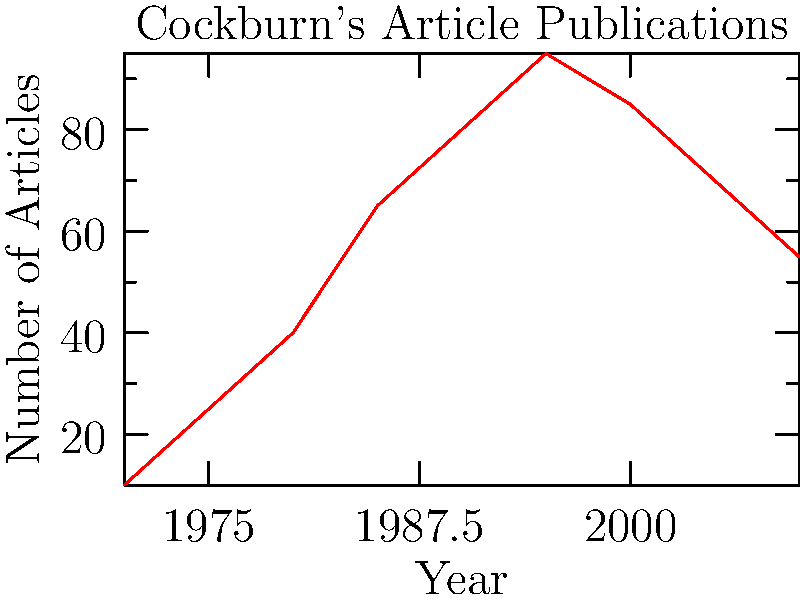Analyze the trend in Alexander Cockburn's article publications from 1970 to 2010 as shown in the line graph. What significant shift occurred around the year 2000, and how might this relate to changes in the media landscape during that period? To answer this question, we need to examine the line graph carefully and interpret the data in the context of media studies:

1. Observe the overall trend: From 1970 to 2000, there's a steady increase in the number of articles published by Cockburn.

2. Identify the peak: The number of articles reaches its maximum around 1995-2000, with approximately 95 articles published.

3. Note the shift: After 2000, there's a noticeable decline in the number of articles published.

4. Quantify the decline: From 2000 to 2010, the number of articles drops from about 85 to 55, a decrease of roughly 35%.

5. Consider the media landscape: The early 2000s saw the rise of digital media and blogging platforms. This shift might have affected traditional print journalism, where Cockburn was primarily active.

6. Reflect on Cockburn's career: As an established journalist, Cockburn might have shifted his focus to longer-form writing (books) or adapted to new media formats not captured in this graph.

7. Media studies context: This trend could reflect broader changes in journalism, such as the decline of print media and the increasing importance of online platforms.
Answer: Around 2000, Cockburn's article publications began declining significantly, possibly due to the rise of digital media and changing journalism practices. 